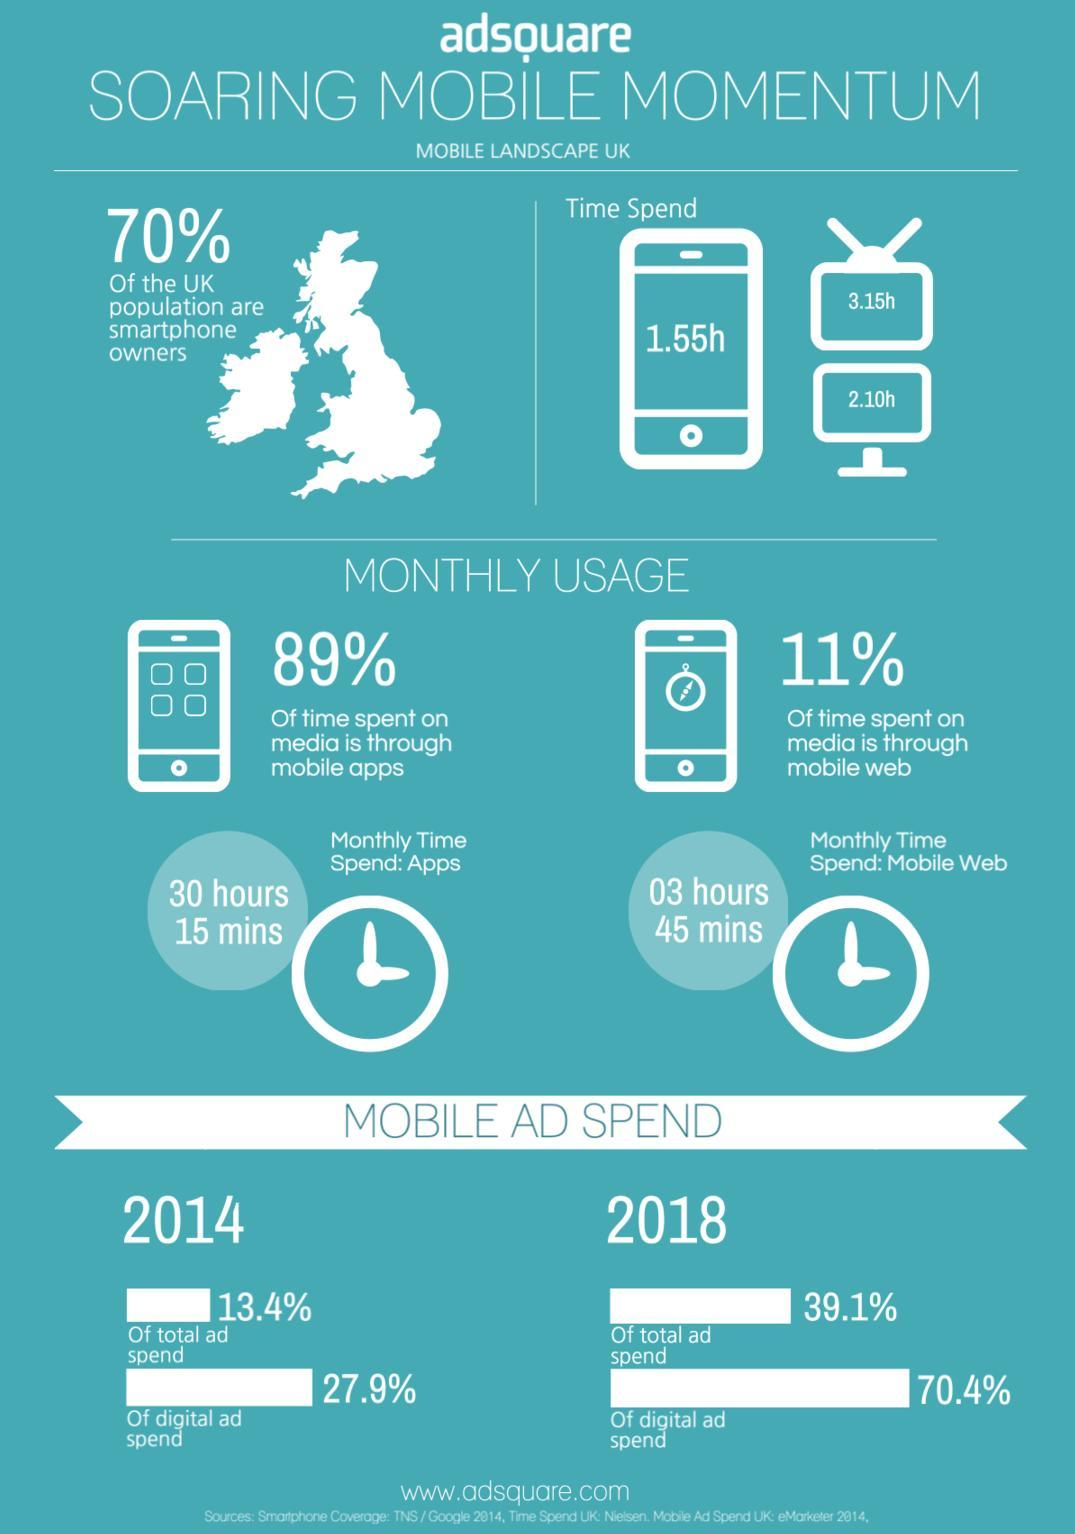What percentage of total ad spend in UK is for mobile ad in 2014?
Answer the question with a short phrase. 13.4% What percentage of digital ad spend in UK is for mobile ad in 2018? 70.4% What percentage of total ad spend in UK is for mobile ad in 2018? 39.1% What percentage of digital ad spend in UK is for mobile ad in 2014? 27.9% What is the total time spend by the UK people in computers? 2.10h What percentage of time spent on media is through mobile web in UK? 11% What percentage of the UK population do not own smartphones? 30% What is the monthly time spend on mobile apps by the UK people? 30 hours 15 mins What is the total time spend by the UK people in watching TV? 3.15h What is the total time spend by the UK people in smartphones? 1.55h 